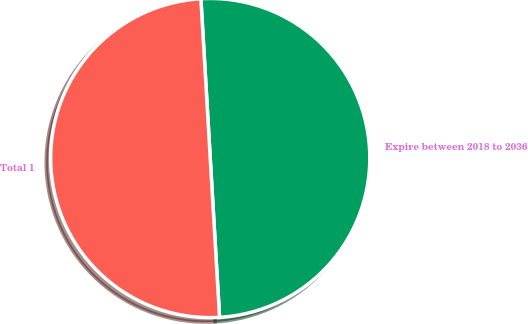Convert chart to OTSL. <chart><loc_0><loc_0><loc_500><loc_500><pie_chart><fcel>Expire between 2018 to 2036<fcel>Total 1<nl><fcel>50.0%<fcel>50.0%<nl></chart> 